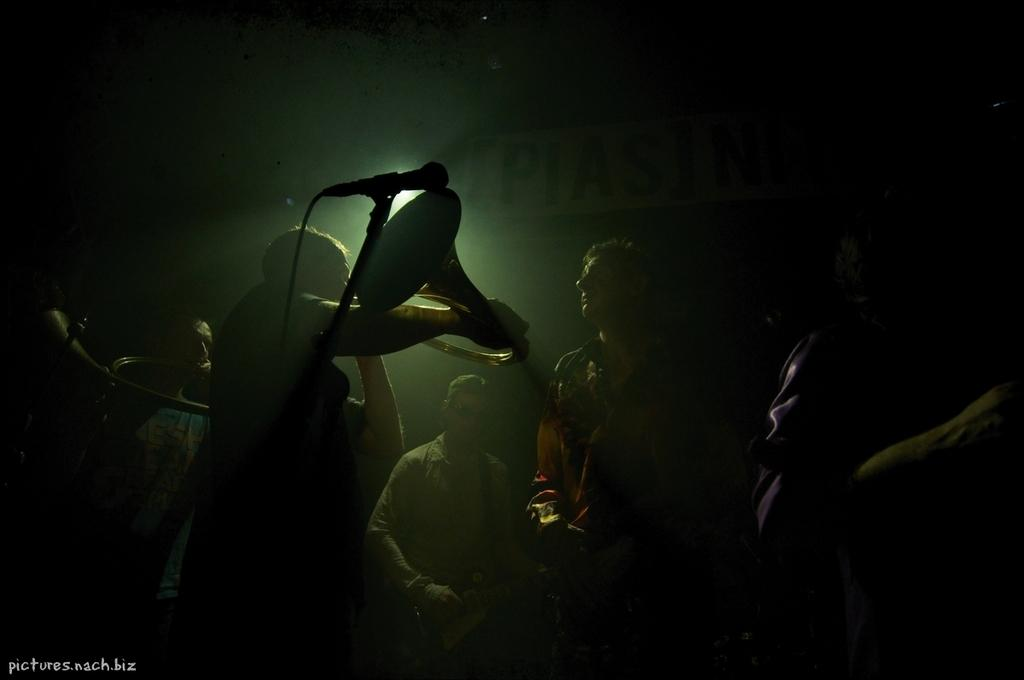What is the overall appearance of the image? The image has a dark appearance. Can you describe the people in the image? There are people standing in the image. What are some of the people doing in the image? Some of the people are holding musical instruments. What equipment is visible in the image? A microphone is visible in the image. What can be inferred about the background of the image? The background of the image is also dark. How does the calendar in the image help the people organize their pleasure activities? There is no calendar present in the image, so it cannot be used to organize pleasure activities. 